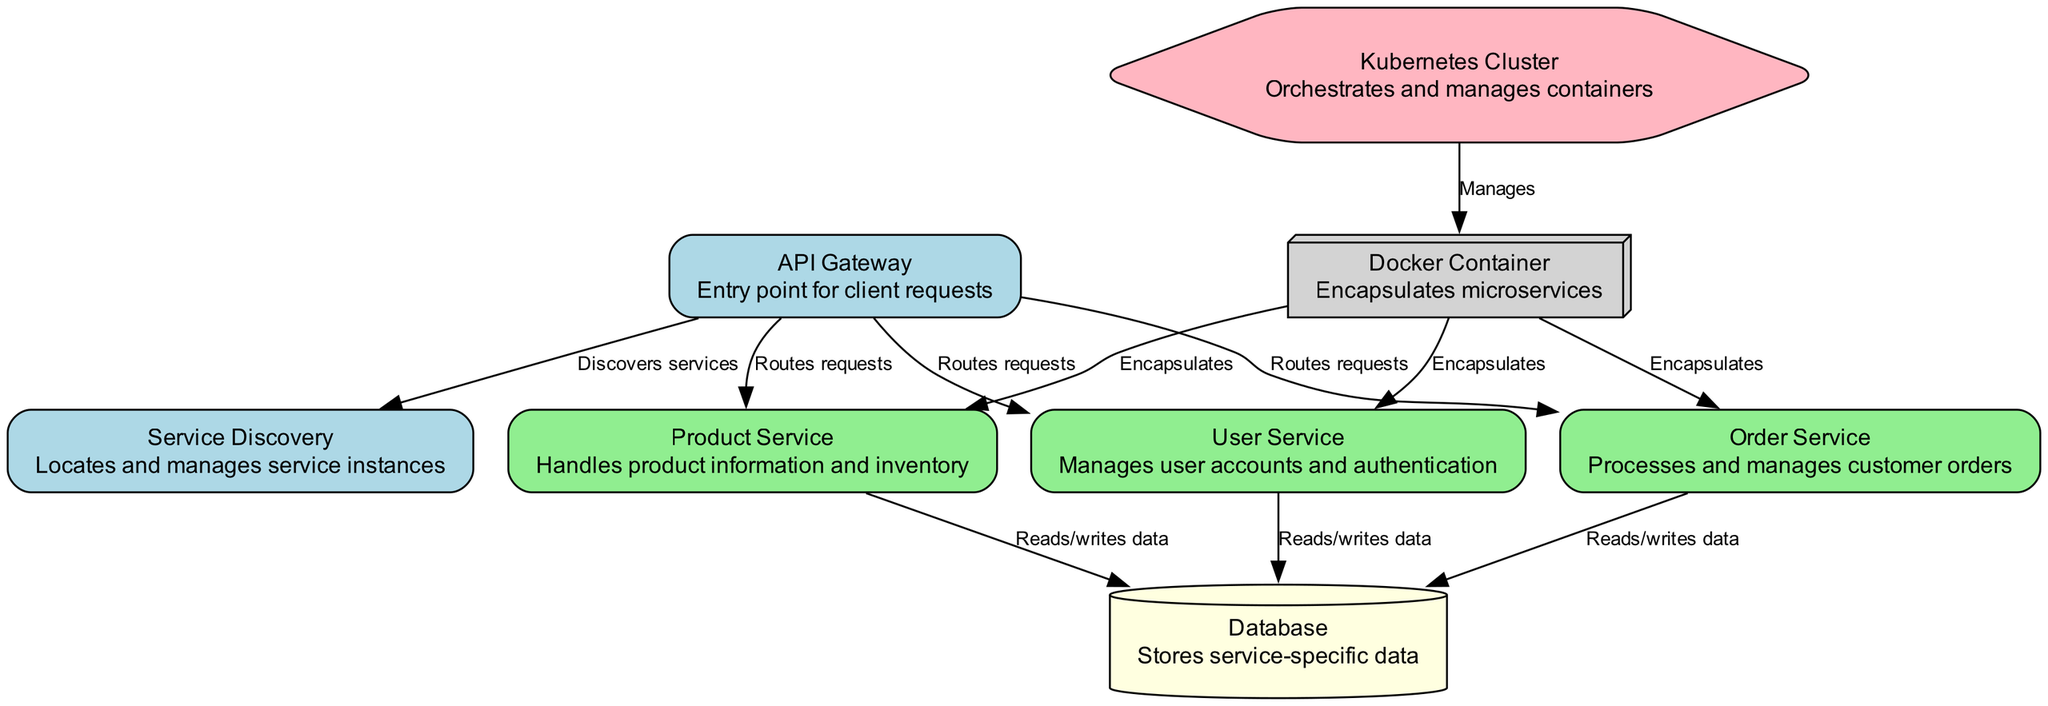What is the entry point for client requests? In the diagram, the node labeled "API Gateway" is defined as the entry point for client requests. This is indicated directly in its description.
Answer: API Gateway How many services are there in total? The diagram contains five distinct service nodes: User Service, Product Service, Order Service, Service Discovery, and API Gateway. Counting these gives a total of five services.
Answer: 5 Which node manages user accounts and authentication? The node named "User Service" in the diagram is specifically described as managing user accounts and authentication, making it the answer to this question.
Answer: User Service What is the role of the Service Discovery node? The description of the "Service Discovery" node states that it locates and manages service instances, identifying its role within the architecture.
Answer: Locates and manages service instances Which service is responsible for processing and managing customer orders? The node labeled "Order Service" has a description indicating that it processes and manages customer orders, directly answering the question.
Answer: Order Service How do the User Service and Product Service interact with the Database? The edges show that both the User Service and Product Service read and write data to the Database. Thus, they interact with the Database through these described operations.
Answer: Reads/writes data Which component encapsulates the microservices? The "Docker Container" is the node specifically described as encapsulating the microservices, making it the correct answer to this question.
Answer: Docker Container How many edges are assigned to the API Gateway? The API Gateway node has three outgoing edges: one to Service Discovery and one each to the User Service, Product Service, and Order Service, totaling four edges.
Answer: 4 What does the Kubernetes Cluster manage? The connection between the "Kubernetes Cluster" and "Docker Container" indicates that it manages these containers, as per the edge label.
Answer: Manages containers 